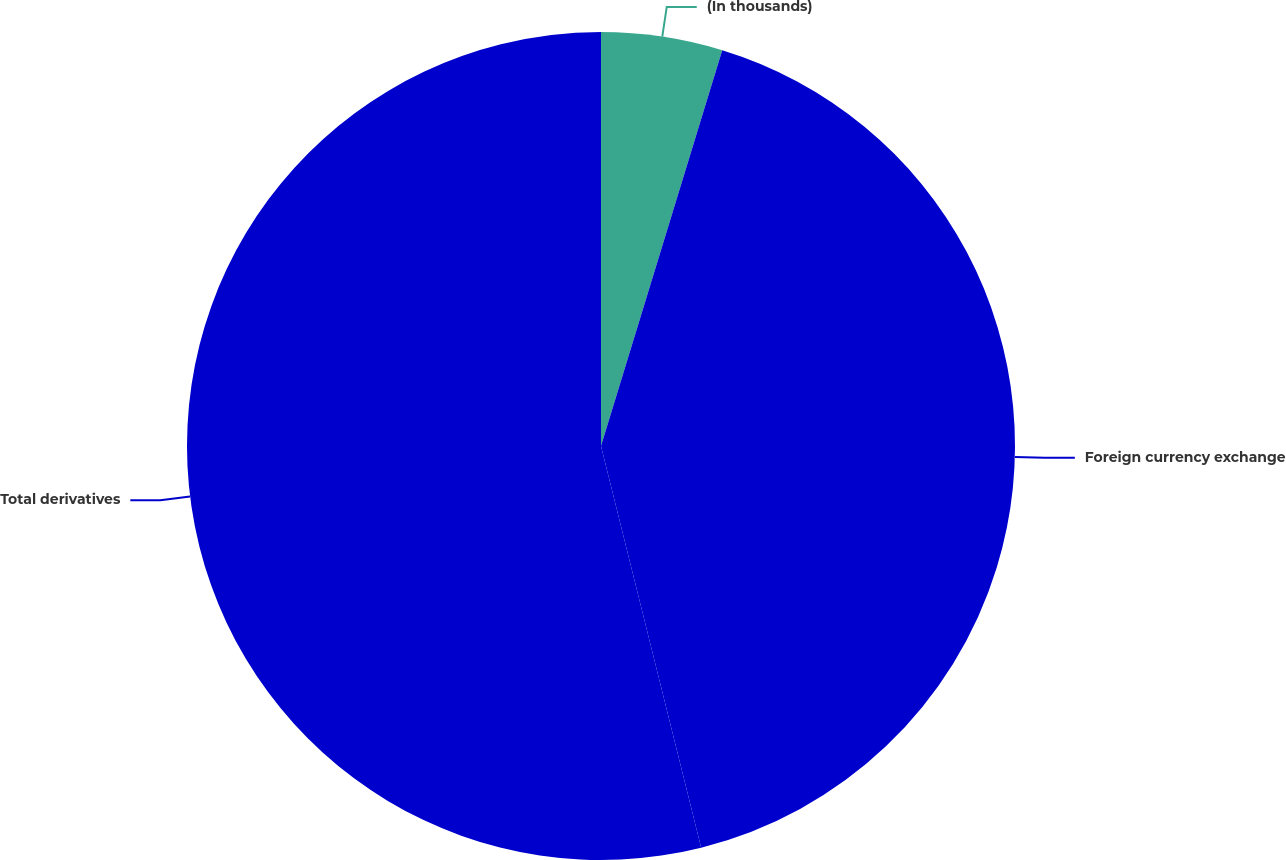<chart> <loc_0><loc_0><loc_500><loc_500><pie_chart><fcel>(In thousands)<fcel>Foreign currency exchange<fcel>Total derivatives<nl><fcel>4.73%<fcel>41.38%<fcel>53.89%<nl></chart> 